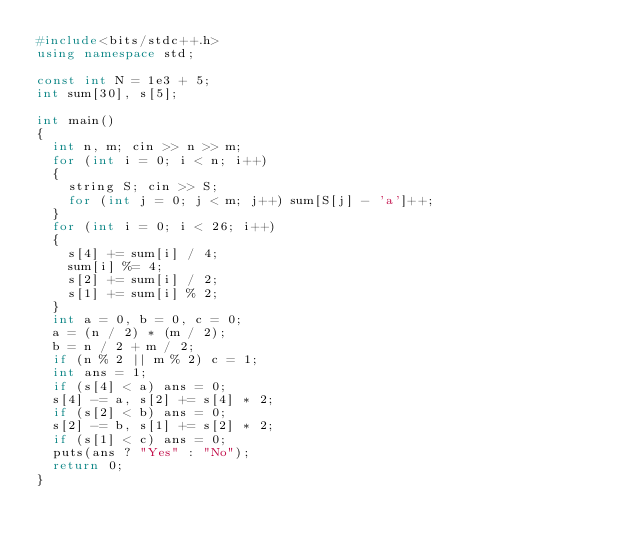<code> <loc_0><loc_0><loc_500><loc_500><_C++_>#include<bits/stdc++.h>
using namespace std;

const int N = 1e3 + 5;
int sum[30], s[5];

int main()
{
	int n, m; cin >> n >> m;
	for (int i = 0; i < n; i++)
	{
		string S; cin >> S;
		for (int j = 0; j < m; j++) sum[S[j] - 'a']++;
	}
	for (int i = 0; i < 26; i++)
	{
		s[4] += sum[i] / 4;
		sum[i] %= 4;
		s[2] += sum[i] / 2;
		s[1] += sum[i] % 2;
	}
	int a = 0, b = 0, c = 0;
	a = (n / 2) * (m / 2);
	b = n / 2 + m / 2;
	if (n % 2 || m % 2) c = 1;
	int ans = 1;
	if (s[4] < a) ans = 0;
	s[4] -= a, s[2] += s[4] * 2;
	if (s[2] < b) ans = 0;
	s[2] -= b, s[1] += s[2] * 2;
	if (s[1] < c) ans = 0;
	puts(ans ? "Yes" : "No");
	return 0;
}</code> 